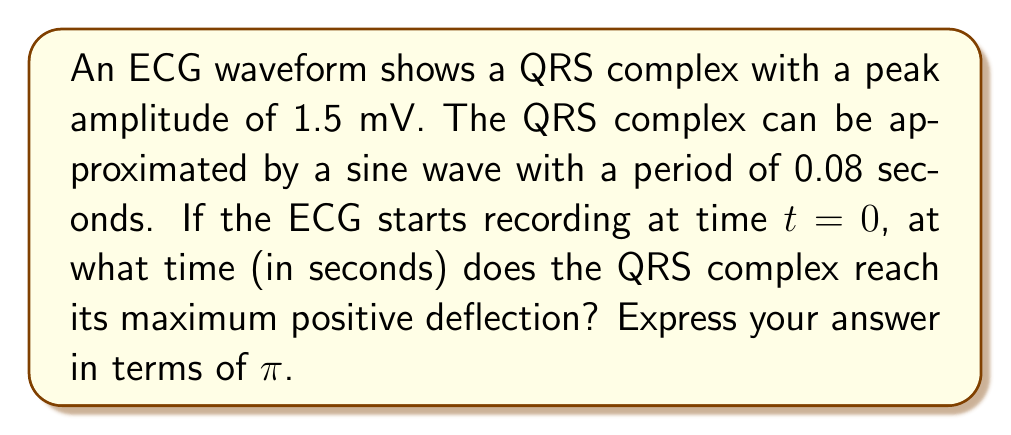Help me with this question. To solve this problem, we need to use the properties of sine waves and their relationship to trigonometric functions. Let's approach this step-by-step:

1) The general equation for a sine wave is:

   $$ y = A \sin(2\pi f t + \phi) $$

   Where:
   - $A$ is the amplitude
   - $f$ is the frequency
   - $t$ is the time
   - $\phi$ is the phase shift

2) We're given that the amplitude $A = 1.5$ mV and the period $T = 0.08$ seconds.

3) The frequency $f$ is the inverse of the period:

   $$ f = \frac{1}{T} = \frac{1}{0.08} = 12.5 \text{ Hz} $$

4) The sine wave reaches its maximum positive deflection when the angle inside the sine function equals $\frac{\pi}{2}$ radians (or 90°). So we need to solve:

   $$ 2\pi f t = \frac{\pi}{2} $$

5) Substituting our frequency:

   $$ 2\pi (12.5) t = \frac{\pi}{2} $$

6) Solving for $t$:

   $$ t = \frac{\frac{\pi}{2}}{2\pi (12.5)} = \frac{\pi}{4\pi (12.5)} = \frac{1}{4(12.5)} = \frac{1}{50} = 0.02 \text{ seconds} $$

7) To express this in terms of π, we can write:

   $$ t = \frac{\pi}{4\pi (12.5)} = \frac{\pi}{50\pi} = \frac{1}{50}\pi \text{ seconds} $$

Thus, the QRS complex reaches its maximum positive deflection at $\frac{1}{50}\pi$ seconds, or $0.02$ seconds.
Answer: $\frac{1}{50}\pi$ seconds 